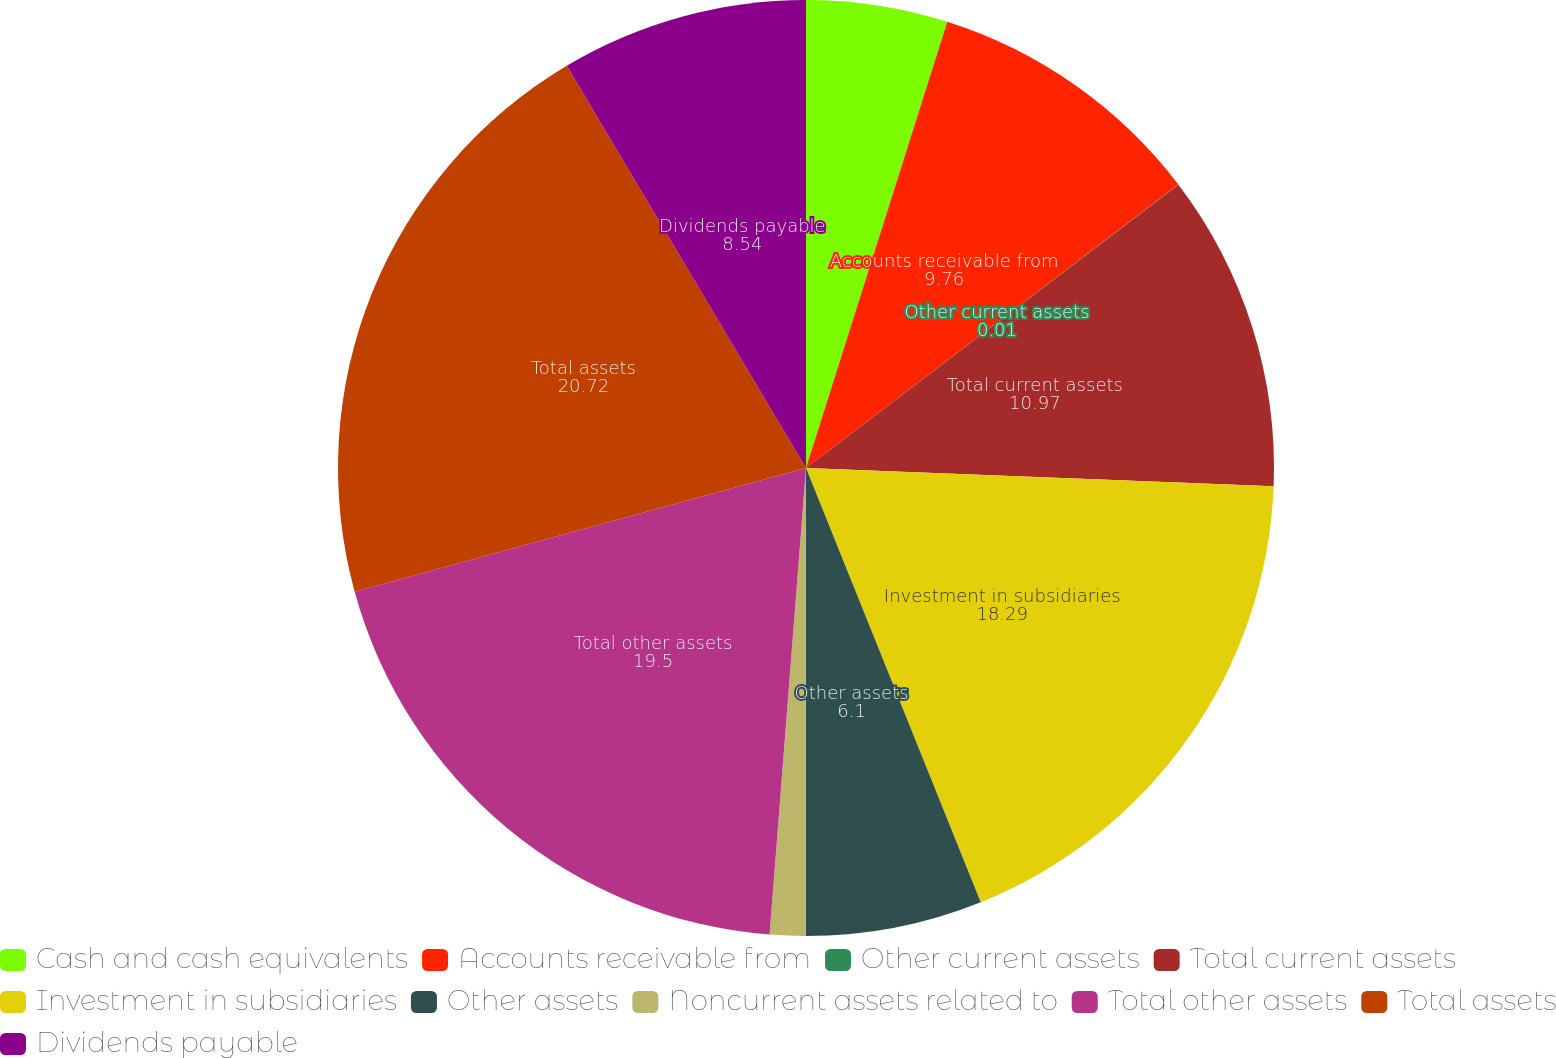<chart> <loc_0><loc_0><loc_500><loc_500><pie_chart><fcel>Cash and cash equivalents<fcel>Accounts receivable from<fcel>Other current assets<fcel>Total current assets<fcel>Investment in subsidiaries<fcel>Other assets<fcel>Noncurrent assets related to<fcel>Total other assets<fcel>Total assets<fcel>Dividends payable<nl><fcel>4.88%<fcel>9.76%<fcel>0.01%<fcel>10.97%<fcel>18.29%<fcel>6.1%<fcel>1.23%<fcel>19.5%<fcel>20.72%<fcel>8.54%<nl></chart> 